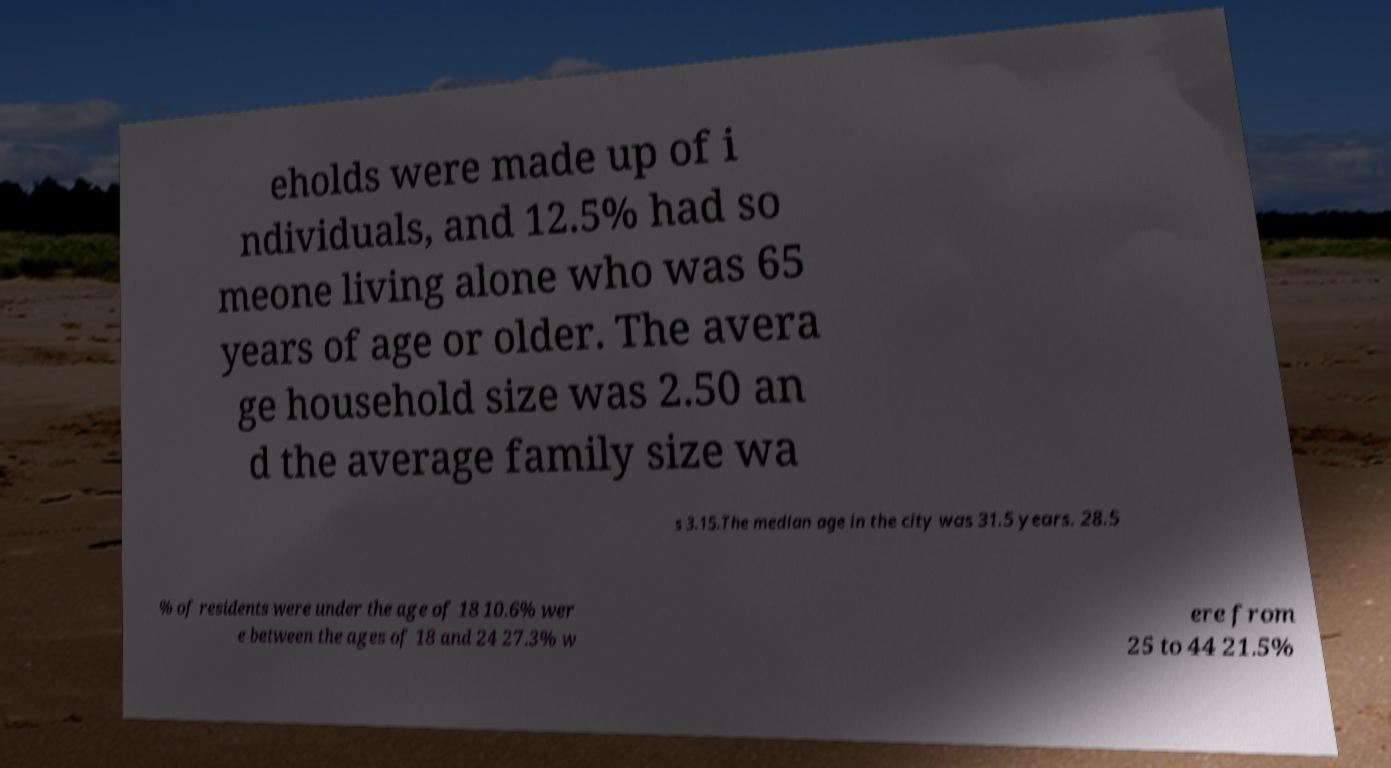What messages or text are displayed in this image? I need them in a readable, typed format. eholds were made up of i ndividuals, and 12.5% had so meone living alone who was 65 years of age or older. The avera ge household size was 2.50 an d the average family size wa s 3.15.The median age in the city was 31.5 years. 28.5 % of residents were under the age of 18 10.6% wer e between the ages of 18 and 24 27.3% w ere from 25 to 44 21.5% 